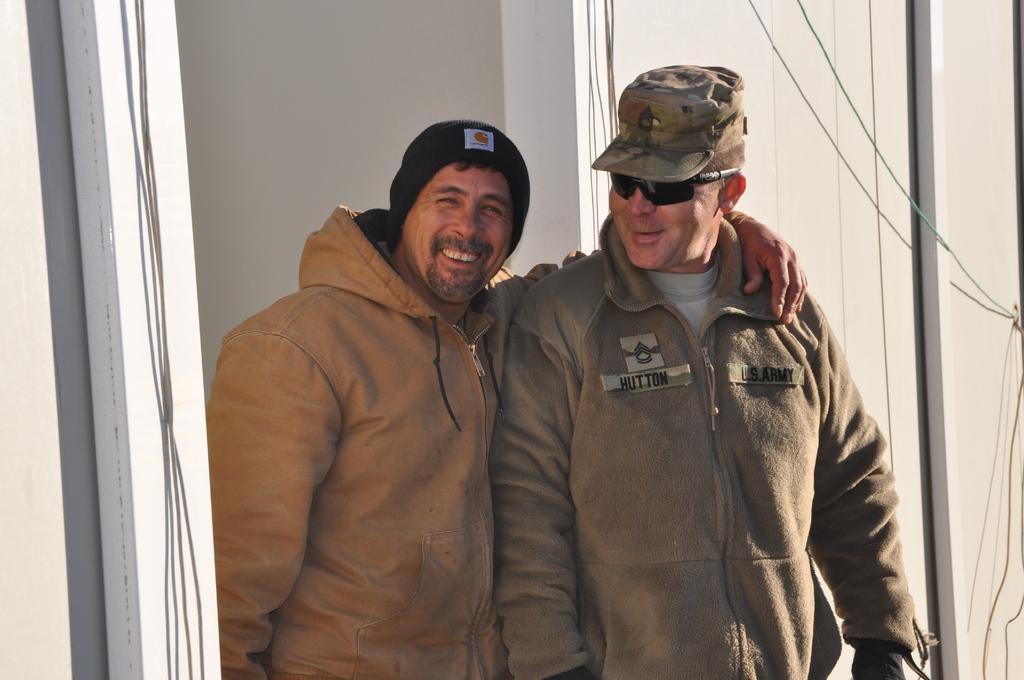Describe this image in one or two sentences. In this image, we can see persons in front of the wall. These persons are wearing clothes and caps. 